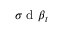<formula> <loc_0><loc_0><loc_500><loc_500>\sigma d \beta _ { t }</formula> 